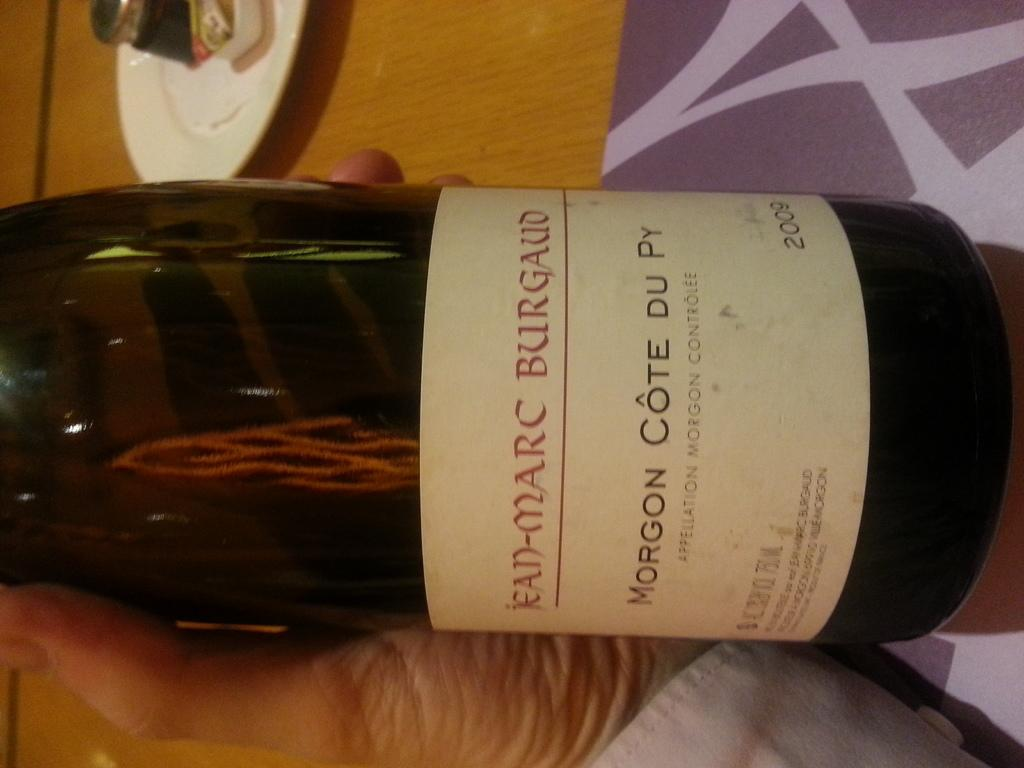What is the human hand holding in the image? The human hand is holding a wine bottle in the image. What can be seen on the wine bottle? There is text on the wine bottle. What is present on the table in the image? There is a plate on the table in the image. What type of light is being emitted from the dock in the image? There is no dock present in the image, so it is not possible to determine what type of light might be emitted from it. 